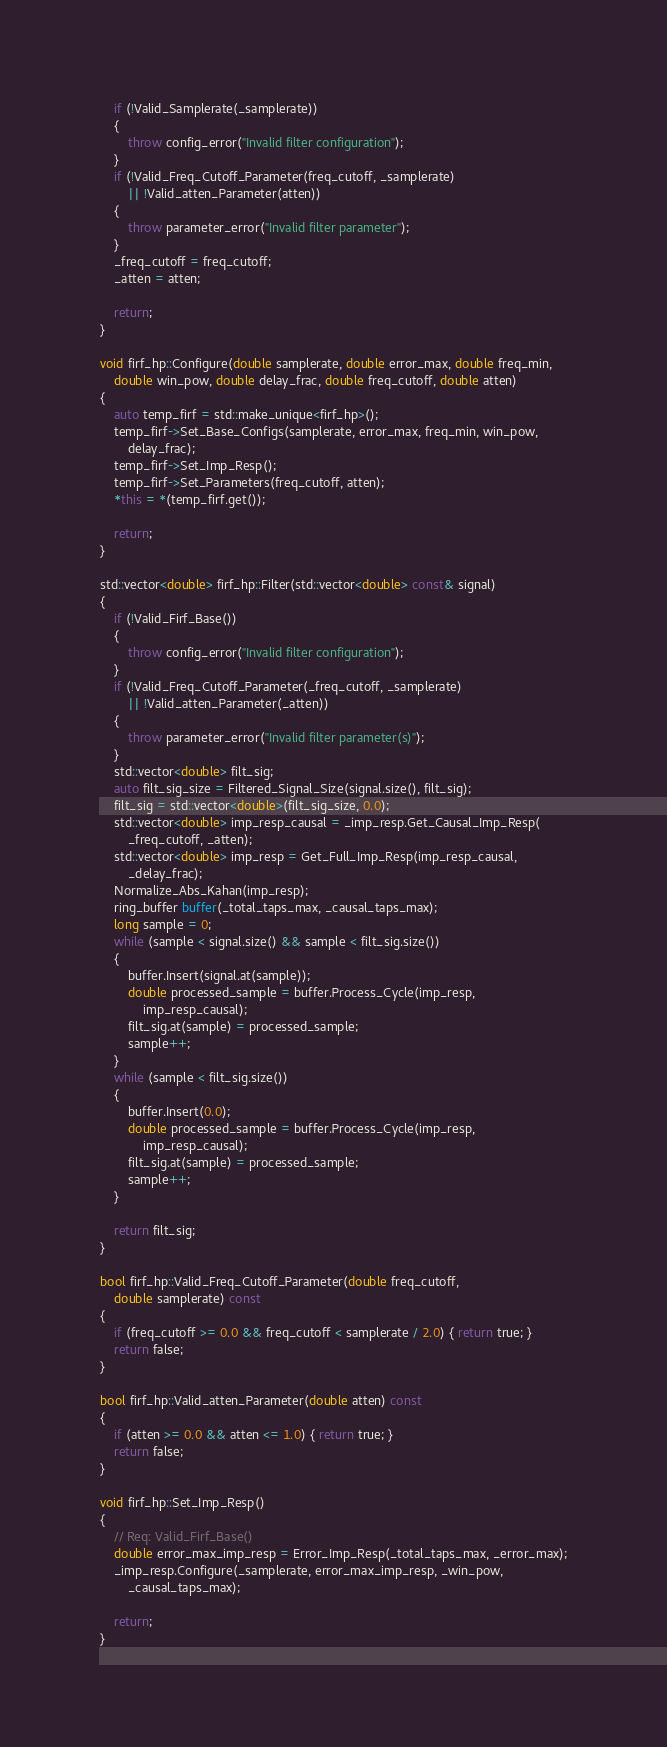Convert code to text. <code><loc_0><loc_0><loc_500><loc_500><_C++_>	if (!Valid_Samplerate(_samplerate))
	{
		throw config_error("Invalid filter configuration");
	}
	if (!Valid_Freq_Cutoff_Parameter(freq_cutoff, _samplerate)
		|| !Valid_atten_Parameter(atten))
	{
		throw parameter_error("Invalid filter parameter");
	}
	_freq_cutoff = freq_cutoff;
	_atten = atten;

	return;
}

void firf_hp::Configure(double samplerate, double error_max, double freq_min,
	double win_pow, double delay_frac, double freq_cutoff, double atten)
{
	auto temp_firf = std::make_unique<firf_hp>();
	temp_firf->Set_Base_Configs(samplerate, error_max, freq_min, win_pow,
		delay_frac);
	temp_firf->Set_Imp_Resp();
	temp_firf->Set_Parameters(freq_cutoff, atten);
	*this = *(temp_firf.get());

	return;
}

std::vector<double> firf_hp::Filter(std::vector<double> const& signal)
{
	if (!Valid_Firf_Base())
	{
		throw config_error("Invalid filter configuration");
	}
	if (!Valid_Freq_Cutoff_Parameter(_freq_cutoff, _samplerate)
		|| !Valid_atten_Parameter(_atten))
	{
		throw parameter_error("Invalid filter parameter(s)");
	}
	std::vector<double> filt_sig;
	auto filt_sig_size = Filtered_Signal_Size(signal.size(), filt_sig);
	filt_sig = std::vector<double>(filt_sig_size, 0.0);
	std::vector<double> imp_resp_causal = _imp_resp.Get_Causal_Imp_Resp(
		_freq_cutoff, _atten);
	std::vector<double> imp_resp = Get_Full_Imp_Resp(imp_resp_causal,
		_delay_frac);
	Normalize_Abs_Kahan(imp_resp);
	ring_buffer buffer(_total_taps_max, _causal_taps_max);
	long sample = 0;
	while (sample < signal.size() && sample < filt_sig.size())
	{
		buffer.Insert(signal.at(sample));
		double processed_sample = buffer.Process_Cycle(imp_resp,
			imp_resp_causal);
		filt_sig.at(sample) = processed_sample;
		sample++;
	}
	while (sample < filt_sig.size())
	{
		buffer.Insert(0.0);
		double processed_sample = buffer.Process_Cycle(imp_resp,
			imp_resp_causal);
		filt_sig.at(sample) = processed_sample;
		sample++;
	}

	return filt_sig;
}

bool firf_hp::Valid_Freq_Cutoff_Parameter(double freq_cutoff,
	double samplerate) const
{
	if (freq_cutoff >= 0.0 && freq_cutoff < samplerate / 2.0) { return true; }
	return false;
}

bool firf_hp::Valid_atten_Parameter(double atten) const
{
	if (atten >= 0.0 && atten <= 1.0) { return true; }
	return false;
}

void firf_hp::Set_Imp_Resp()
{
	// Req: Valid_Firf_Base()
	double error_max_imp_resp = Error_Imp_Resp(_total_taps_max, _error_max);
	_imp_resp.Configure(_samplerate, error_max_imp_resp, _win_pow,
		_causal_taps_max);

	return;
}
</code> 